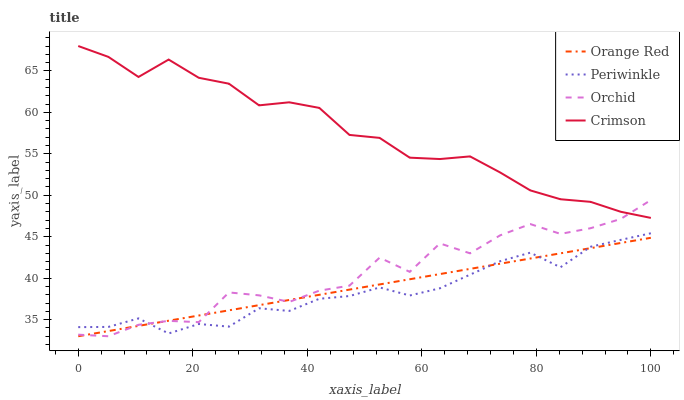Does Periwinkle have the minimum area under the curve?
Answer yes or no. Yes. Does Crimson have the maximum area under the curve?
Answer yes or no. Yes. Does Orange Red have the minimum area under the curve?
Answer yes or no. No. Does Orange Red have the maximum area under the curve?
Answer yes or no. No. Is Orange Red the smoothest?
Answer yes or no. Yes. Is Orchid the roughest?
Answer yes or no. Yes. Is Periwinkle the smoothest?
Answer yes or no. No. Is Periwinkle the roughest?
Answer yes or no. No. Does Periwinkle have the lowest value?
Answer yes or no. No. Does Crimson have the highest value?
Answer yes or no. Yes. Does Periwinkle have the highest value?
Answer yes or no. No. Is Periwinkle less than Crimson?
Answer yes or no. Yes. Is Crimson greater than Orange Red?
Answer yes or no. Yes. Does Crimson intersect Orchid?
Answer yes or no. Yes. Is Crimson less than Orchid?
Answer yes or no. No. Is Crimson greater than Orchid?
Answer yes or no. No. Does Periwinkle intersect Crimson?
Answer yes or no. No. 